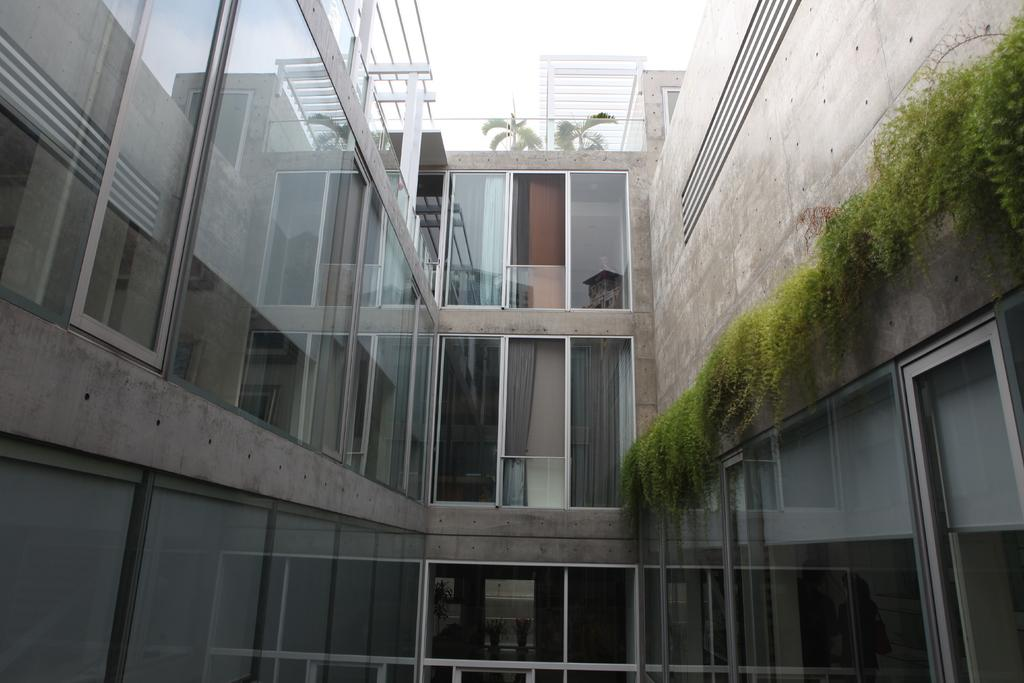What type of structure is present in the image? There is a building in the image. What are some features of the building? The building has walls, windows, and doors. What else can be seen in the image besides the building? There are plants, iron bars, and two trees in the image. What is visible at the top of the image? The sky is visible at the top of the image. Can you tell me how many owls are perched on the iron bars in the image? There are no owls present in the image; only plants, iron bars, and trees can be seen. What type of debt is associated with the building in the image? There is no mention of debt in the image or related to the building. 